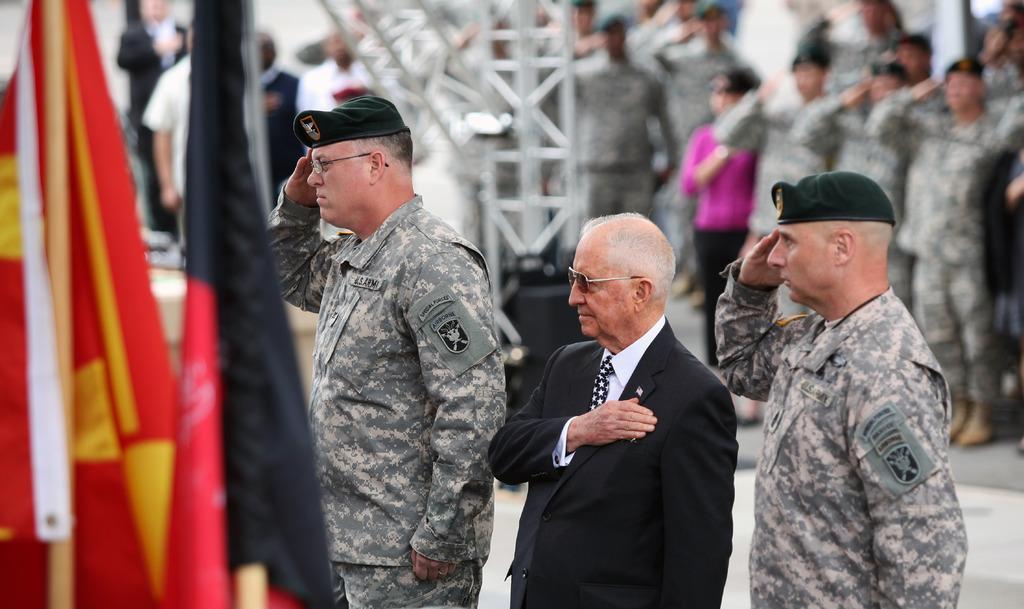How would you summarize this image in a sentence or two? In this image we can see three men standing. On the left side we can see the flags to the wooden poles. On the backside we can see the metal frame, a wall and a group of people standing on the ground. 